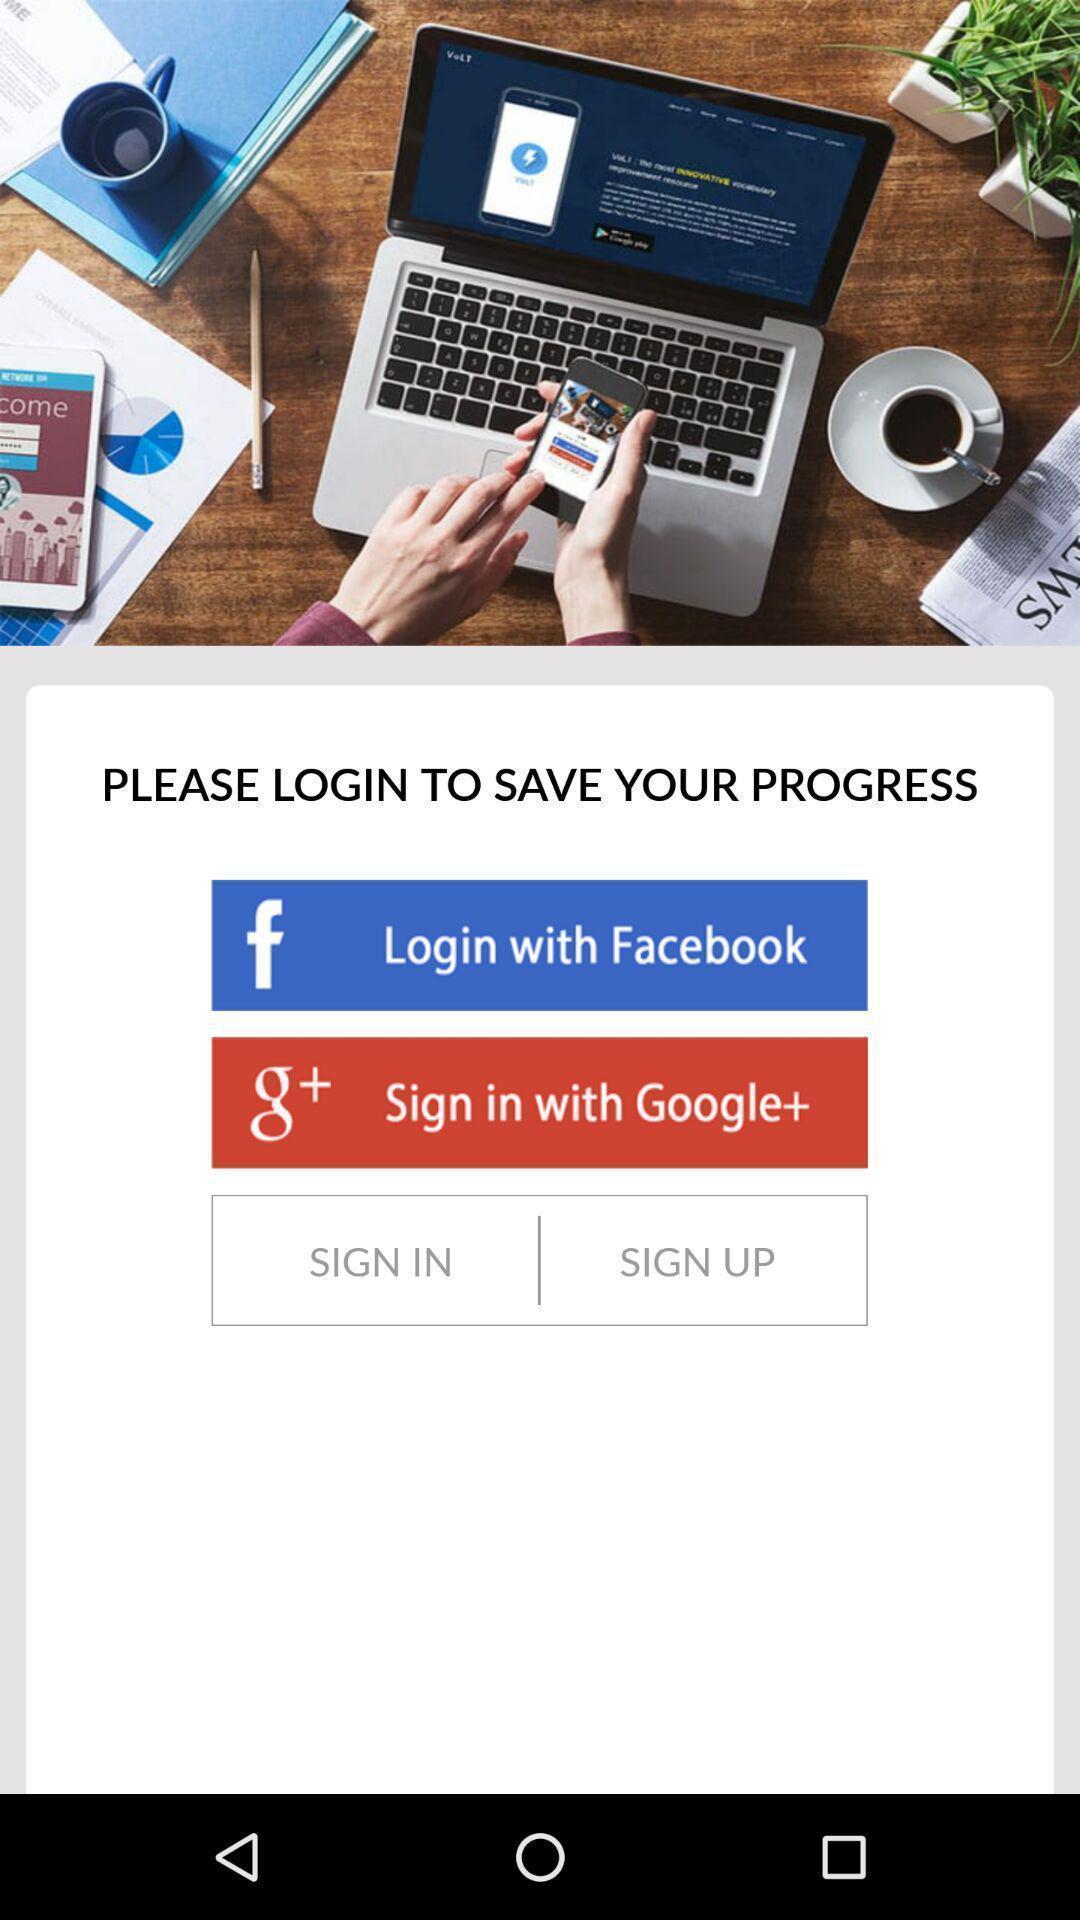Describe the visual elements of this screenshot. Sign in page. 